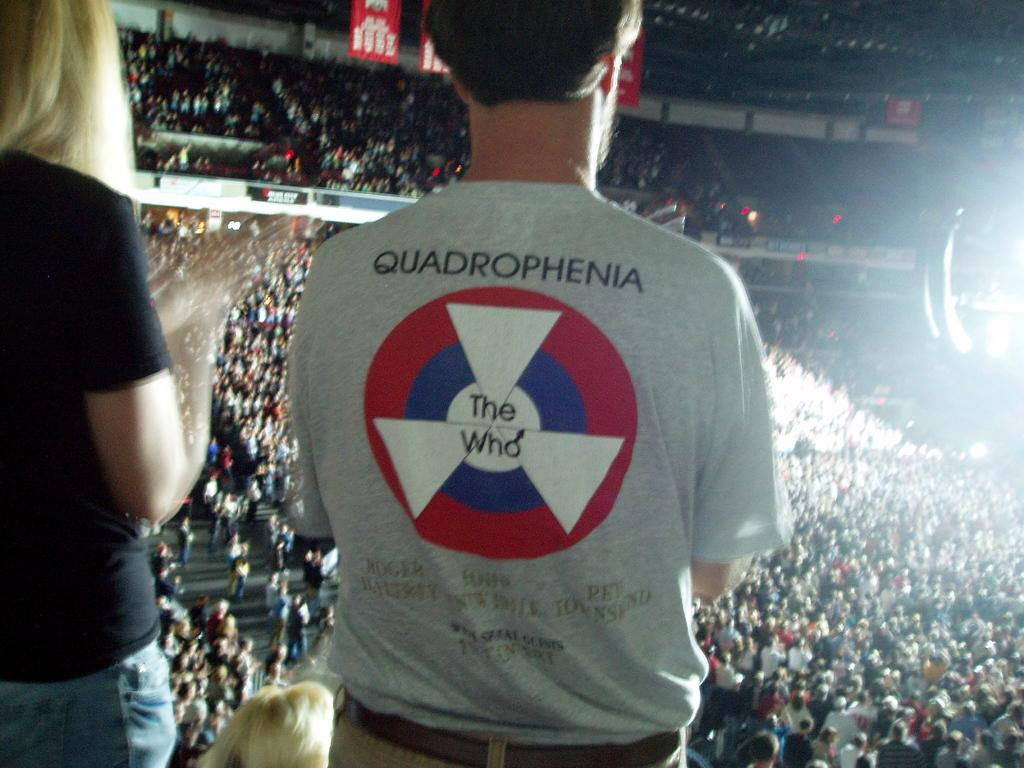<image>
Share a concise interpretation of the image provided. the word quadrophenia that is on a shirt 